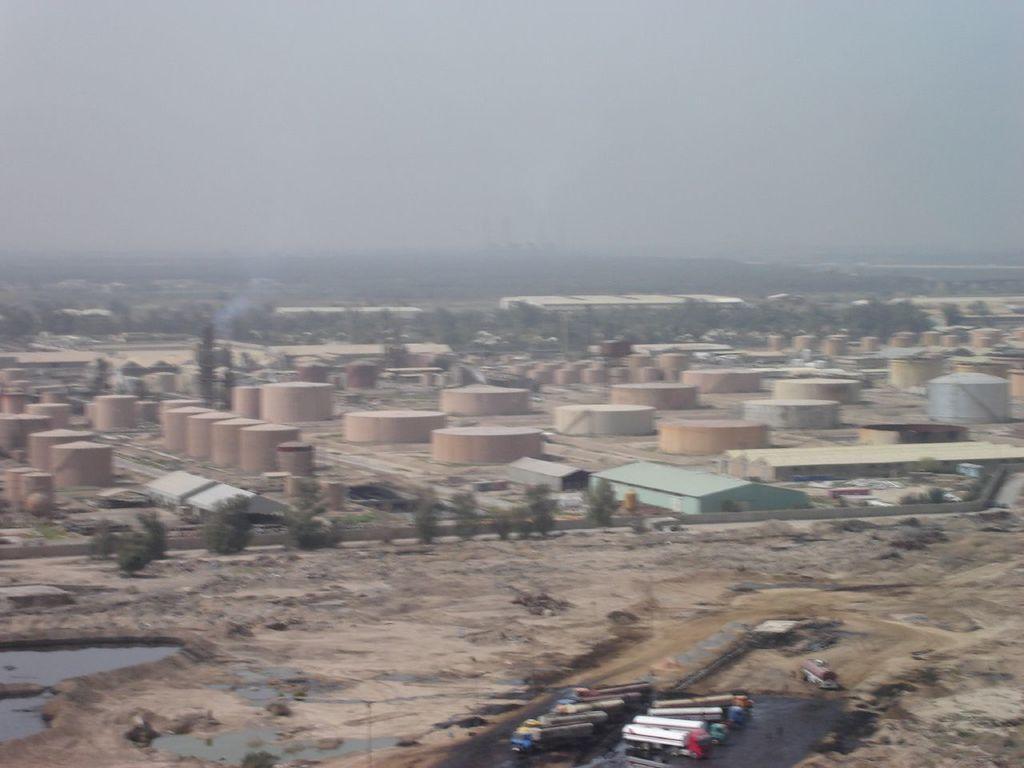In one or two sentences, can you explain what this image depicts? In this picture we can see shed, round buildings, trees and plants. On the top we can see sky and clouds. On the bottom we can see some machines in this black area. On the bottom left corner we can see black liquid. 